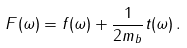<formula> <loc_0><loc_0><loc_500><loc_500>F ( \omega ) = f ( \omega ) + { \frac { 1 } { 2 m _ { b } } } t ( \omega ) \, .</formula> 